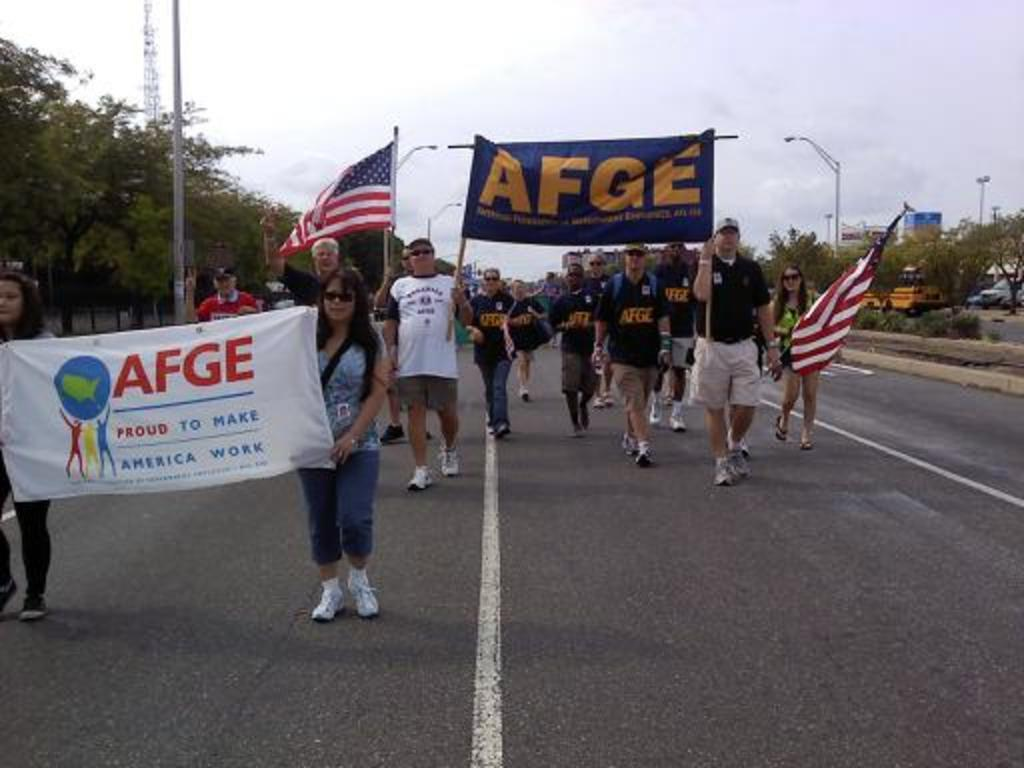What are the people in the image doing on the road? The people in the image are walking on the road. What are the people holding while walking on the road? The people are holding banners and flags. What can be seen beside the road in the image? There are trees and buildings beside the road in the image. Is there a girl having an argument with someone on her birthday in the image? There is no girl or birthday celebration present in the image, nor is there any indication of an argument. 